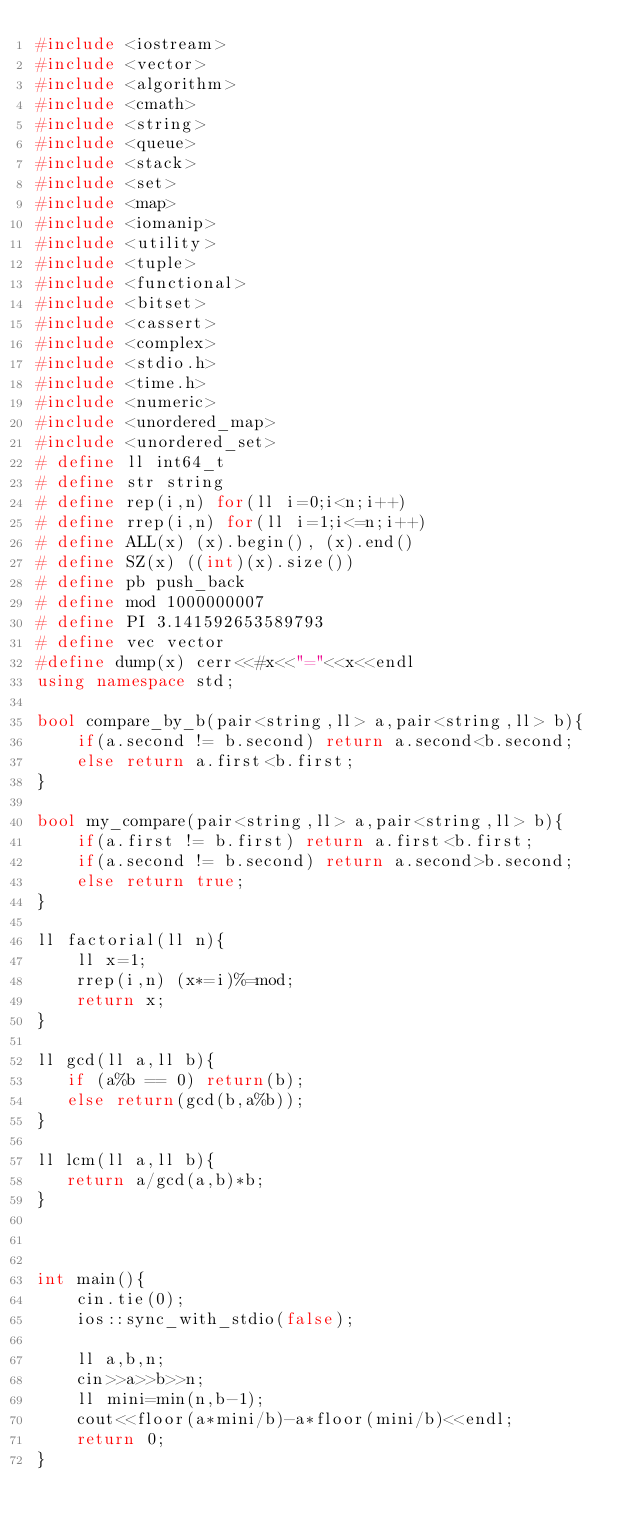Convert code to text. <code><loc_0><loc_0><loc_500><loc_500><_C++_>#include <iostream>
#include <vector>
#include <algorithm>
#include <cmath>
#include <string>
#include <queue>
#include <stack>
#include <set>
#include <map>
#include <iomanip>
#include <utility>
#include <tuple>
#include <functional>
#include <bitset>
#include <cassert>
#include <complex>
#include <stdio.h>
#include <time.h>
#include <numeric>
#include <unordered_map>
#include <unordered_set>
# define ll int64_t
# define str string
# define rep(i,n) for(ll i=0;i<n;i++)
# define rrep(i,n) for(ll i=1;i<=n;i++)
# define ALL(x) (x).begin(), (x).end()
# define SZ(x) ((int)(x).size())
# define pb push_back
# define mod 1000000007
# define PI 3.141592653589793
# define vec vector
#define dump(x) cerr<<#x<<"="<<x<<endl
using namespace std;

bool compare_by_b(pair<string,ll> a,pair<string,ll> b){
    if(a.second != b.second) return a.second<b.second;
    else return a.first<b.first;
}

bool my_compare(pair<string,ll> a,pair<string,ll> b){
    if(a.first != b.first) return a.first<b.first;
    if(a.second != b.second) return a.second>b.second;
    else return true;
}

ll factorial(ll n){
    ll x=1;
    rrep(i,n) (x*=i)%=mod;
    return x;
}

ll gcd(ll a,ll b){
   if (a%b == 0) return(b);
   else return(gcd(b,a%b));
}

ll lcm(ll a,ll b){
   return a/gcd(a,b)*b;
}



int main(){
    cin.tie(0);
    ios::sync_with_stdio(false);
    
    ll a,b,n;
    cin>>a>>b>>n;
    ll mini=min(n,b-1);
    cout<<floor(a*mini/b)-a*floor(mini/b)<<endl;
    return 0;
}</code> 